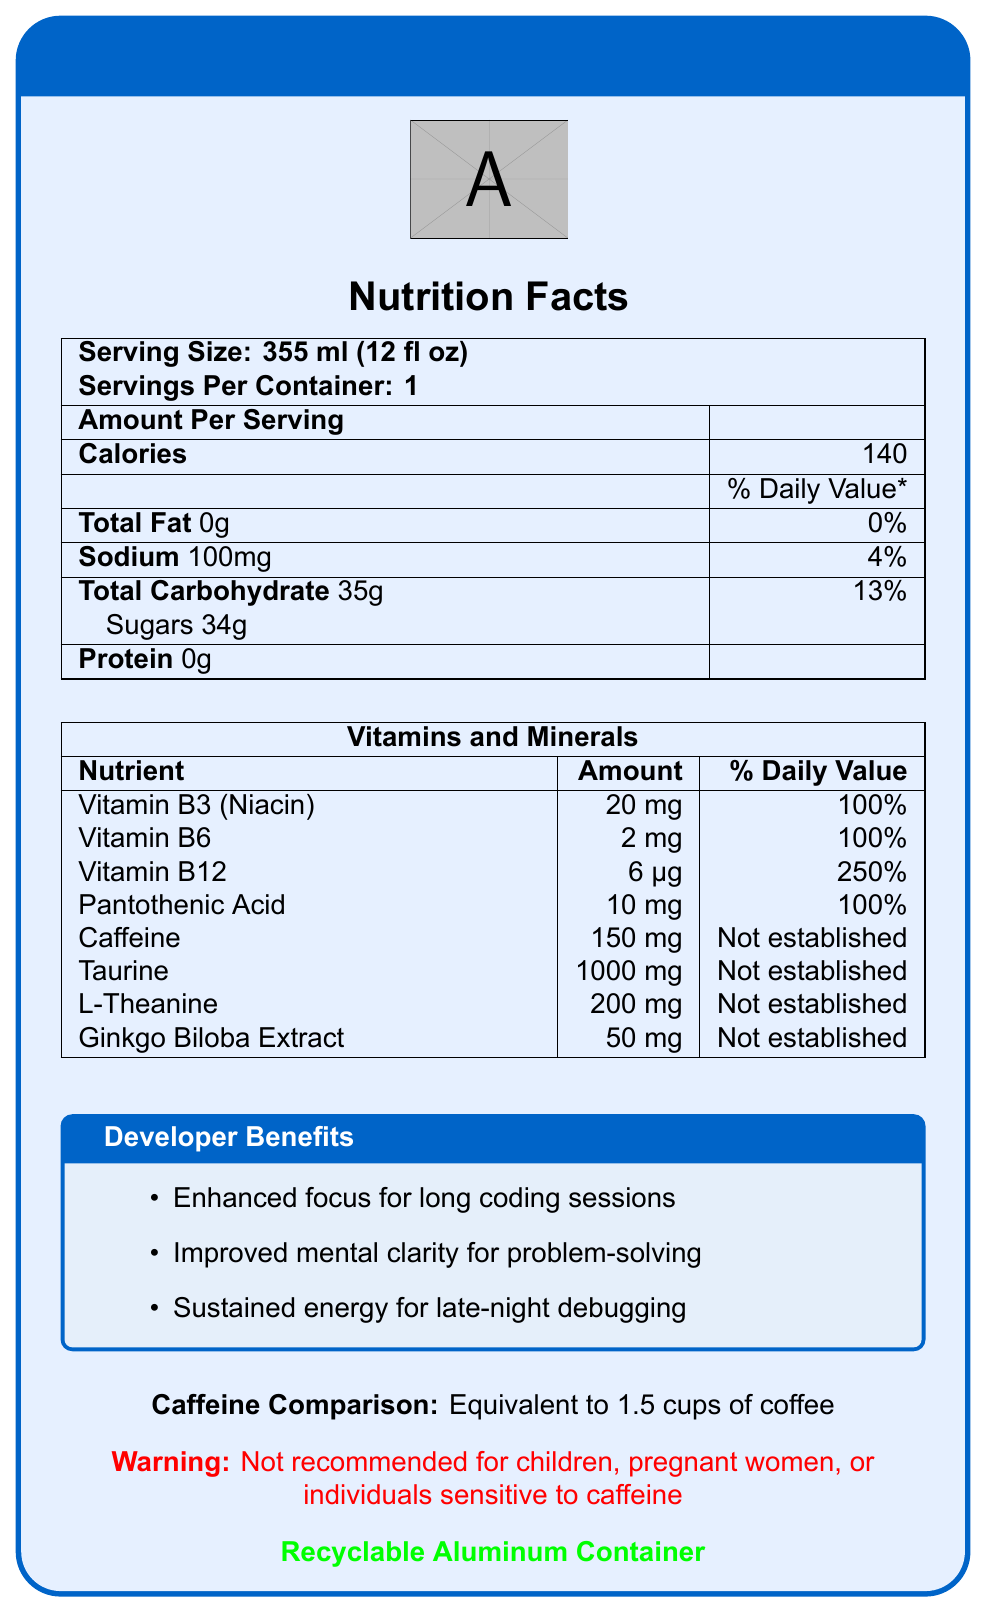what is the serving size of CodeFuel Energy Drink? The serving size is clearly stated at the top of the Nutrition Facts section.
Answer: 355 ml (12 fl oz) how many calories are in one serving? The number of calories is listed in the Nutrition Facts section under Amount Per Serving.
Answer: 140 how much sodium does one serving contain? The sodium content is indicated in the Nutrition Facts section with 4% of the daily value.
Answer: 100 mg name two vitamins that are listed with their % daily value. Vitamins B3 and B12 are listed with their amounts and % daily value in the Vitamins and Minerals section.
Answer: Vitamin B3 (Niacin), Vitamin B12 what is the caffeine content, and how does it compare to coffee? The caffeine content is 150 mg, and the document indicates this is equivalent to 1.5 cups of coffee in the Additional Info section.
Answer: 150 mg, Equivalent to 1.5 cups of coffee which of the following vitamins has the highest % daily value? A. Vitamin B3 (Niacin) B. Vitamin B6 C. Vitamin B12 D. Pantothenic Acid Vitamin B12 has a % daily value of 250%, which is the highest among the listed vitamins.
Answer: C what material is the container made of? The container material is stated at the bottom of the document: "Recyclable Aluminum Container."
Answer: Aluminum does the container comply with recycling standards? The document mentions that the container is recyclable.
Answer: Yes is it safe for children to consume this energy drink? There is a warning in the document stating it is not recommended for children.
Answer: No describe the benefits of CodeFuel Energy Drink as mentioned in the document. The document lists these benefits under the Developer Benefits section.
Answer: Enhanced focus for long coding sessions; Improved mental clarity for problem-solving; Sustained energy for late-night debugging how much sugar does one serving of CodeFuel Energy Drink contain? The sugar content is listed under the Total Carbohydrate section in the Nutrition Facts.
Answer: 34g which ingredient's daily value is not established? A. Vitamin B12 B. Taurine C. Sodium D. Pantothenic Acid Taurine's daily value is listed as "Not established" in the Vitamins and Minerals section.
Answer: B who should avoid consuming this beverage? The warning section of the document mentions these groups.
Answer: Children, pregnant women, individuals sensitive to caffeine can you find the exact amount of caffeine the drink contains? The specific amount of caffeine is listed in the Vitamins and Minerals section.
Answer: 150 mg what is the main message of the document? The document gives an overview of the nutritional content, benefits, and safety warnings of the CodeFuel Energy Drink, designed to support developers in their activities.
Answer: The document provides detailed nutrition facts and benefits of CodeFuel Energy Drink, including its vitamin and mineral content, caffeine comparison, developer benefits, and warnings about its consumption. what is the source of caffeine in this drink? The document provides the amount of caffeine but does not specify its source.
Answer: Cannot be determined 